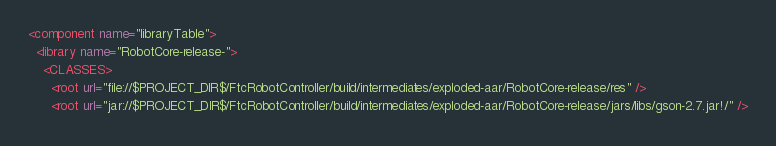<code> <loc_0><loc_0><loc_500><loc_500><_XML_><component name="libraryTable">
  <library name="RobotCore-release-">
    <CLASSES>
      <root url="file://$PROJECT_DIR$/FtcRobotController/build/intermediates/exploded-aar/RobotCore-release/res" />
      <root url="jar://$PROJECT_DIR$/FtcRobotController/build/intermediates/exploded-aar/RobotCore-release/jars/libs/gson-2.7.jar!/" /></code> 